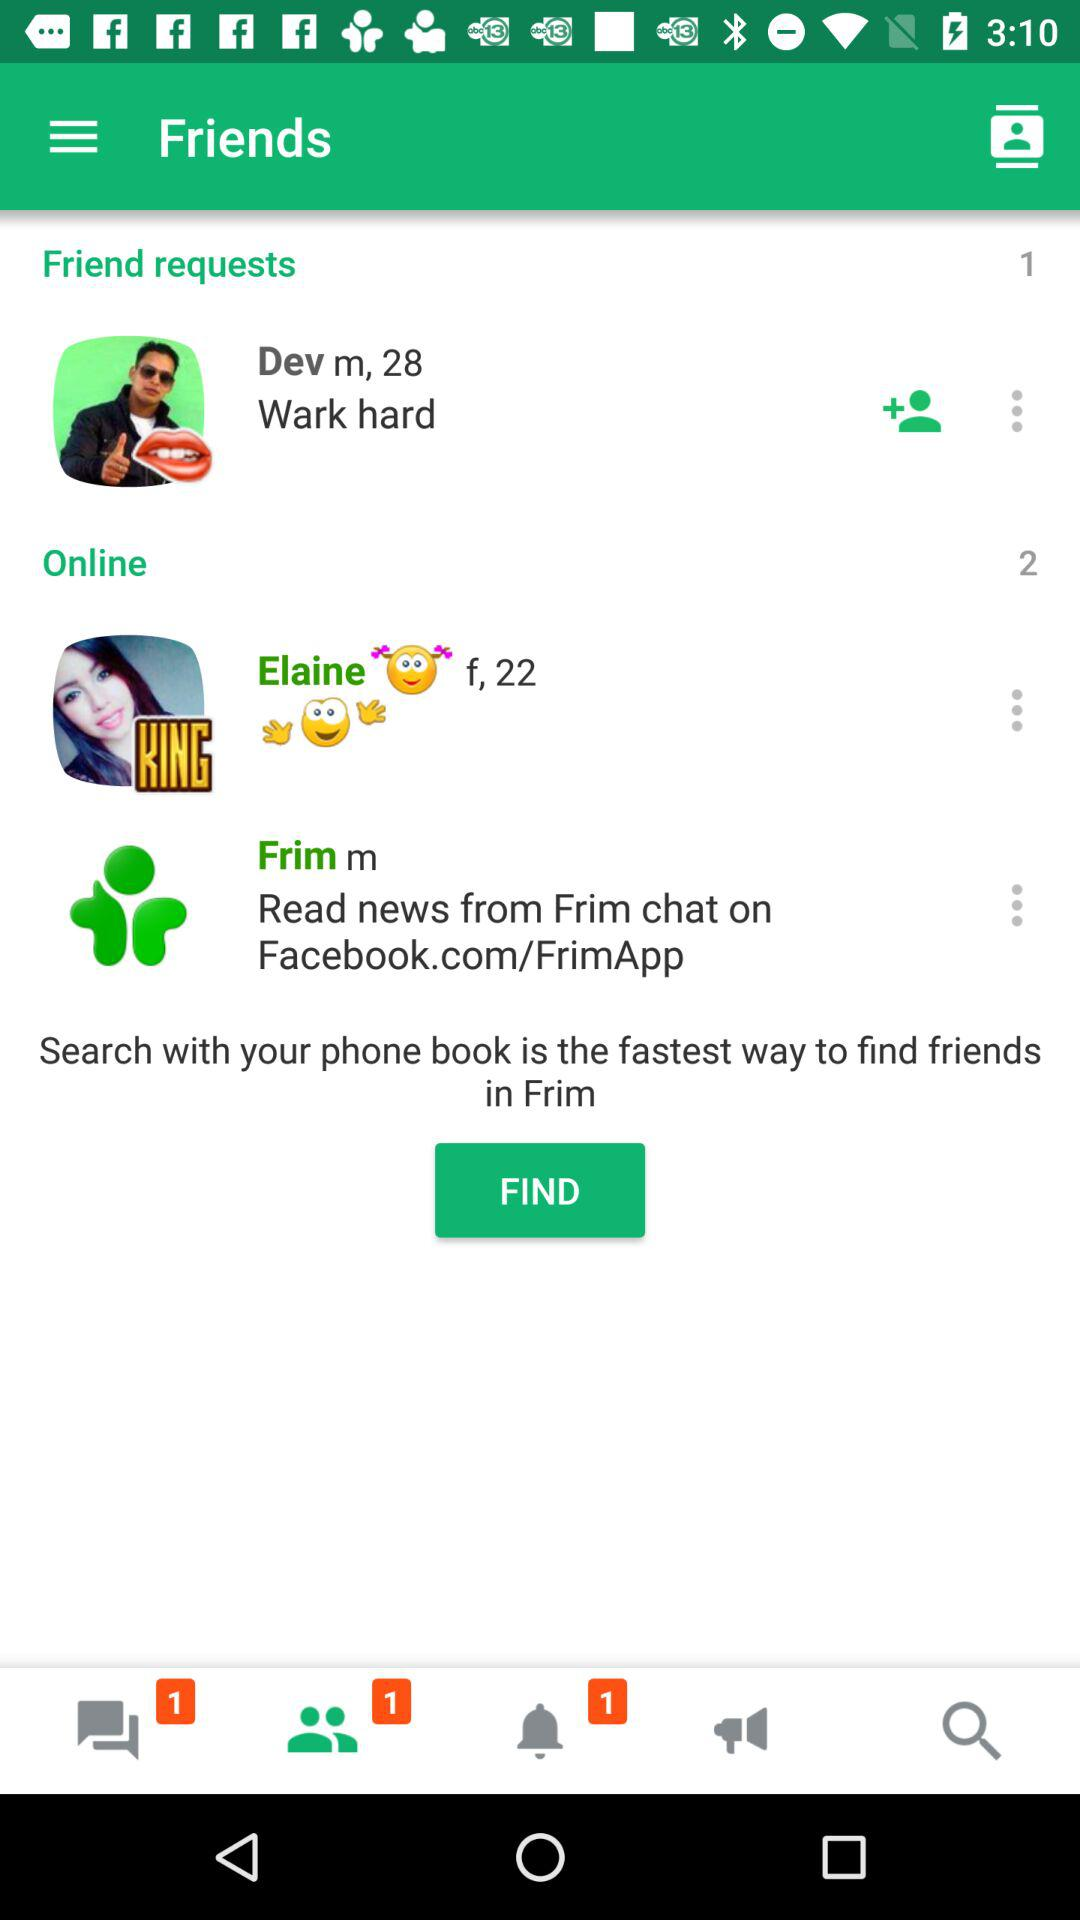What is the gender of Elaine? The gender of Elaine is female. 